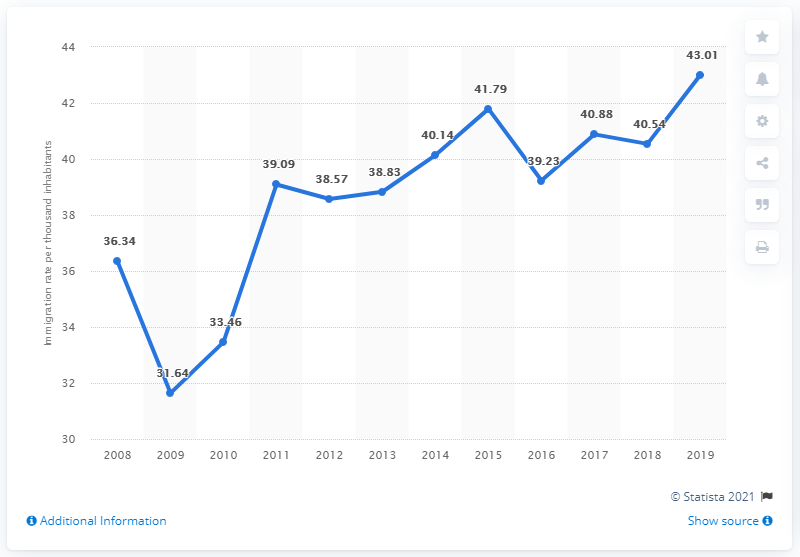Indicate a few pertinent items in this graphic. In 2008, Luxembourg's immigration rate was 36.34. In 2009, Luxembourg had a low immigration rate of 31.64%. In 2019, Luxembourg's immigration rate was 43.01%. 